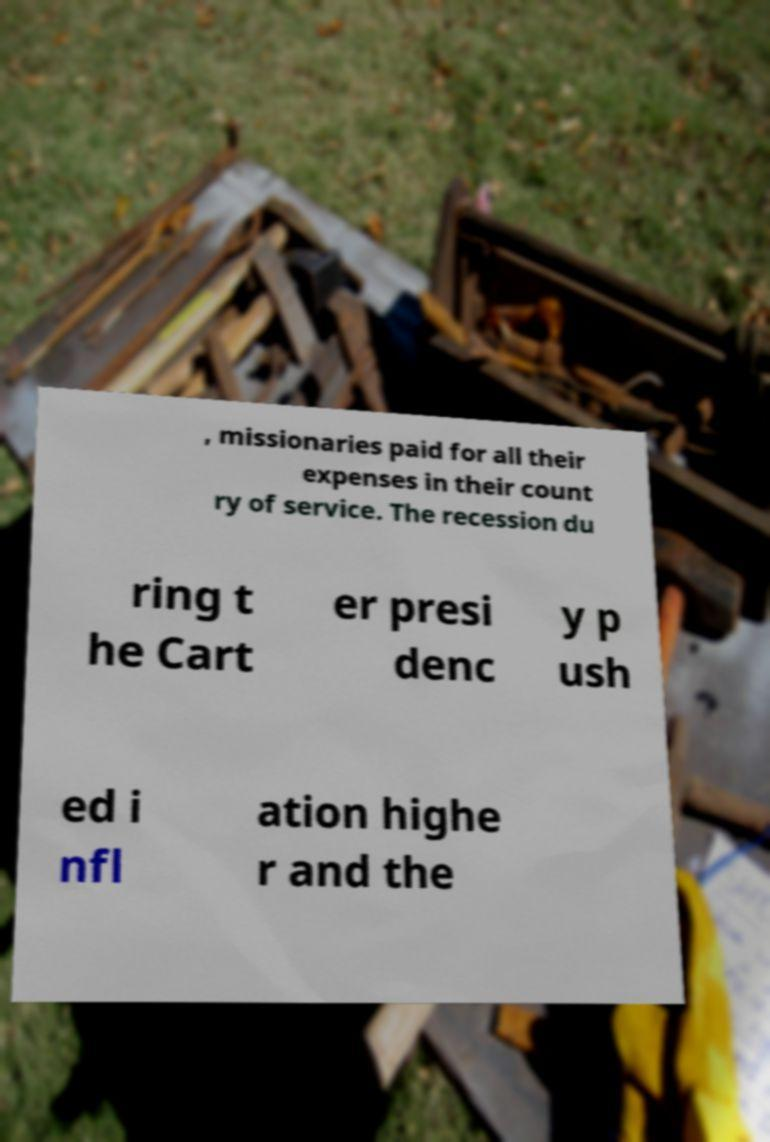I need the written content from this picture converted into text. Can you do that? , missionaries paid for all their expenses in their count ry of service. The recession du ring t he Cart er presi denc y p ush ed i nfl ation highe r and the 